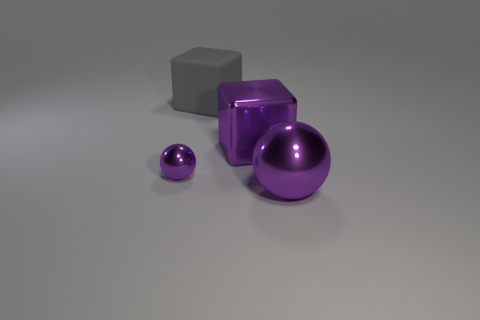There is a cube that is the same color as the small metal sphere; what material is it?
Provide a succinct answer. Metal. What number of big spheres are the same color as the small ball?
Your answer should be compact. 1. Does the purple thing that is behind the small thing have the same material as the gray block?
Provide a short and direct response. No. What material is the small purple ball?
Offer a terse response. Metal. What size is the ball on the right side of the large gray matte block?
Your answer should be compact. Large. Is there any other thing of the same color as the big matte thing?
Provide a short and direct response. No. There is a large metal sphere right of the purple metallic sphere to the left of the big gray cube; are there any shiny spheres behind it?
Keep it short and to the point. Yes. Do the large metal object that is right of the purple block and the tiny object have the same color?
Give a very brief answer. Yes. How many cylinders are either large green objects or tiny purple shiny things?
Your response must be concise. 0. There is a purple object that is in front of the metallic object that is to the left of the big matte thing; what is its shape?
Give a very brief answer. Sphere. 